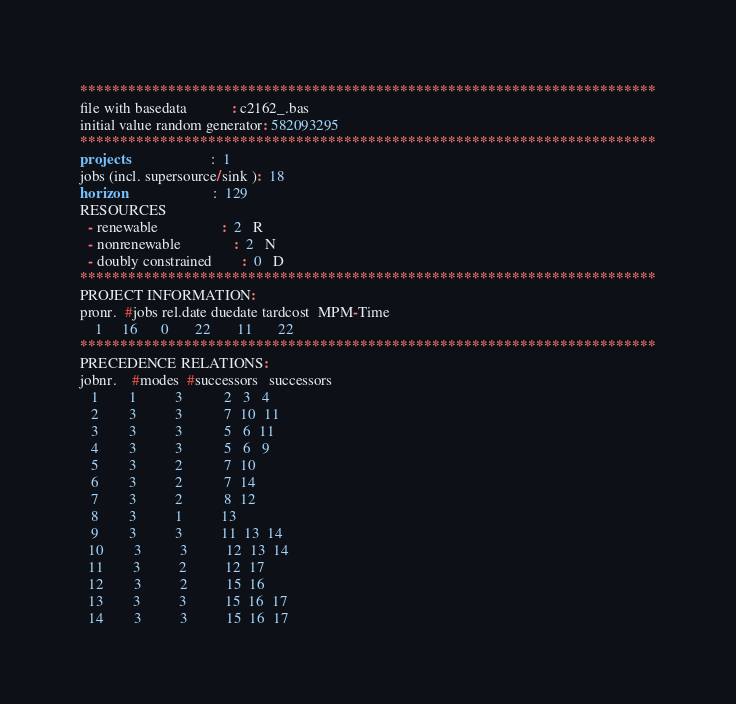Convert code to text. <code><loc_0><loc_0><loc_500><loc_500><_ObjectiveC_>************************************************************************
file with basedata            : c2162_.bas
initial value random generator: 582093295
************************************************************************
projects                      :  1
jobs (incl. supersource/sink ):  18
horizon                       :  129
RESOURCES
  - renewable                 :  2   R
  - nonrenewable              :  2   N
  - doubly constrained        :  0   D
************************************************************************
PROJECT INFORMATION:
pronr.  #jobs rel.date duedate tardcost  MPM-Time
    1     16      0       22       11       22
************************************************************************
PRECEDENCE RELATIONS:
jobnr.    #modes  #successors   successors
   1        1          3           2   3   4
   2        3          3           7  10  11
   3        3          3           5   6  11
   4        3          3           5   6   9
   5        3          2           7  10
   6        3          2           7  14
   7        3          2           8  12
   8        3          1          13
   9        3          3          11  13  14
  10        3          3          12  13  14
  11        3          2          12  17
  12        3          2          15  16
  13        3          3          15  16  17
  14        3          3          15  16  17</code> 